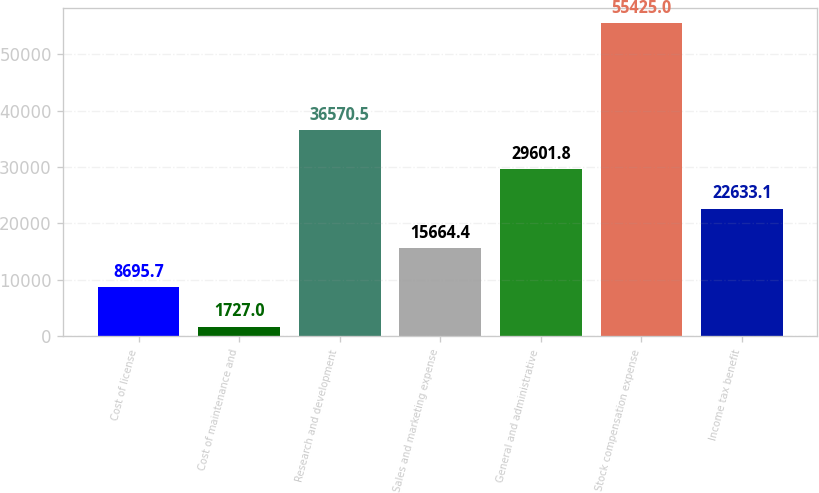Convert chart to OTSL. <chart><loc_0><loc_0><loc_500><loc_500><bar_chart><fcel>Cost of license<fcel>Cost of maintenance and<fcel>Research and development<fcel>Sales and marketing expense<fcel>General and administrative<fcel>Stock compensation expense<fcel>Income tax benefit<nl><fcel>8695.7<fcel>1727<fcel>36570.5<fcel>15664.4<fcel>29601.8<fcel>55425<fcel>22633.1<nl></chart> 